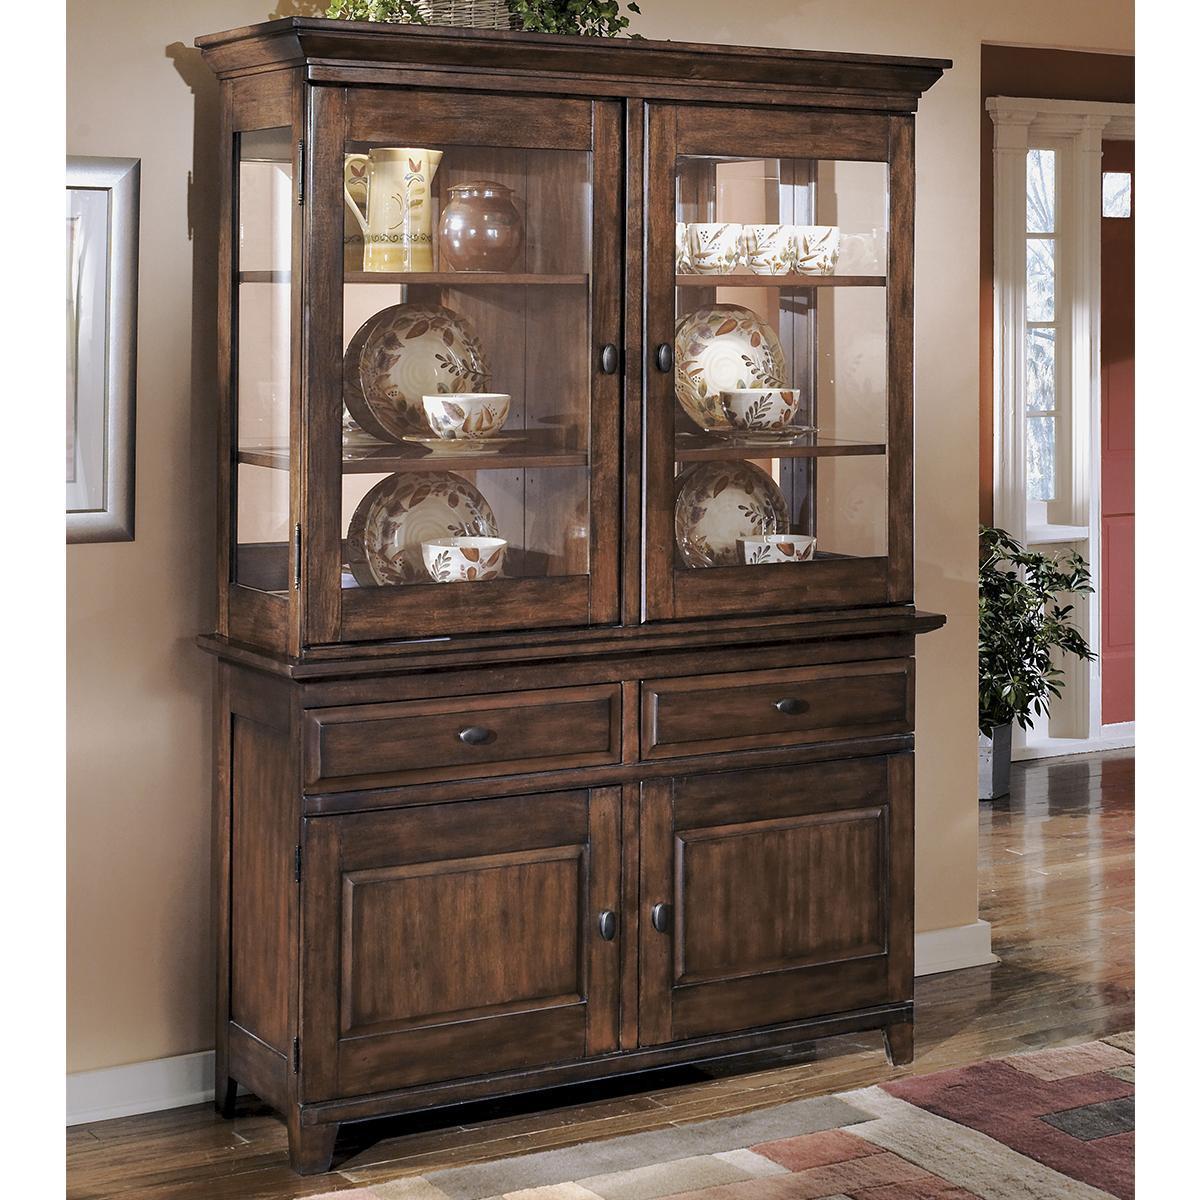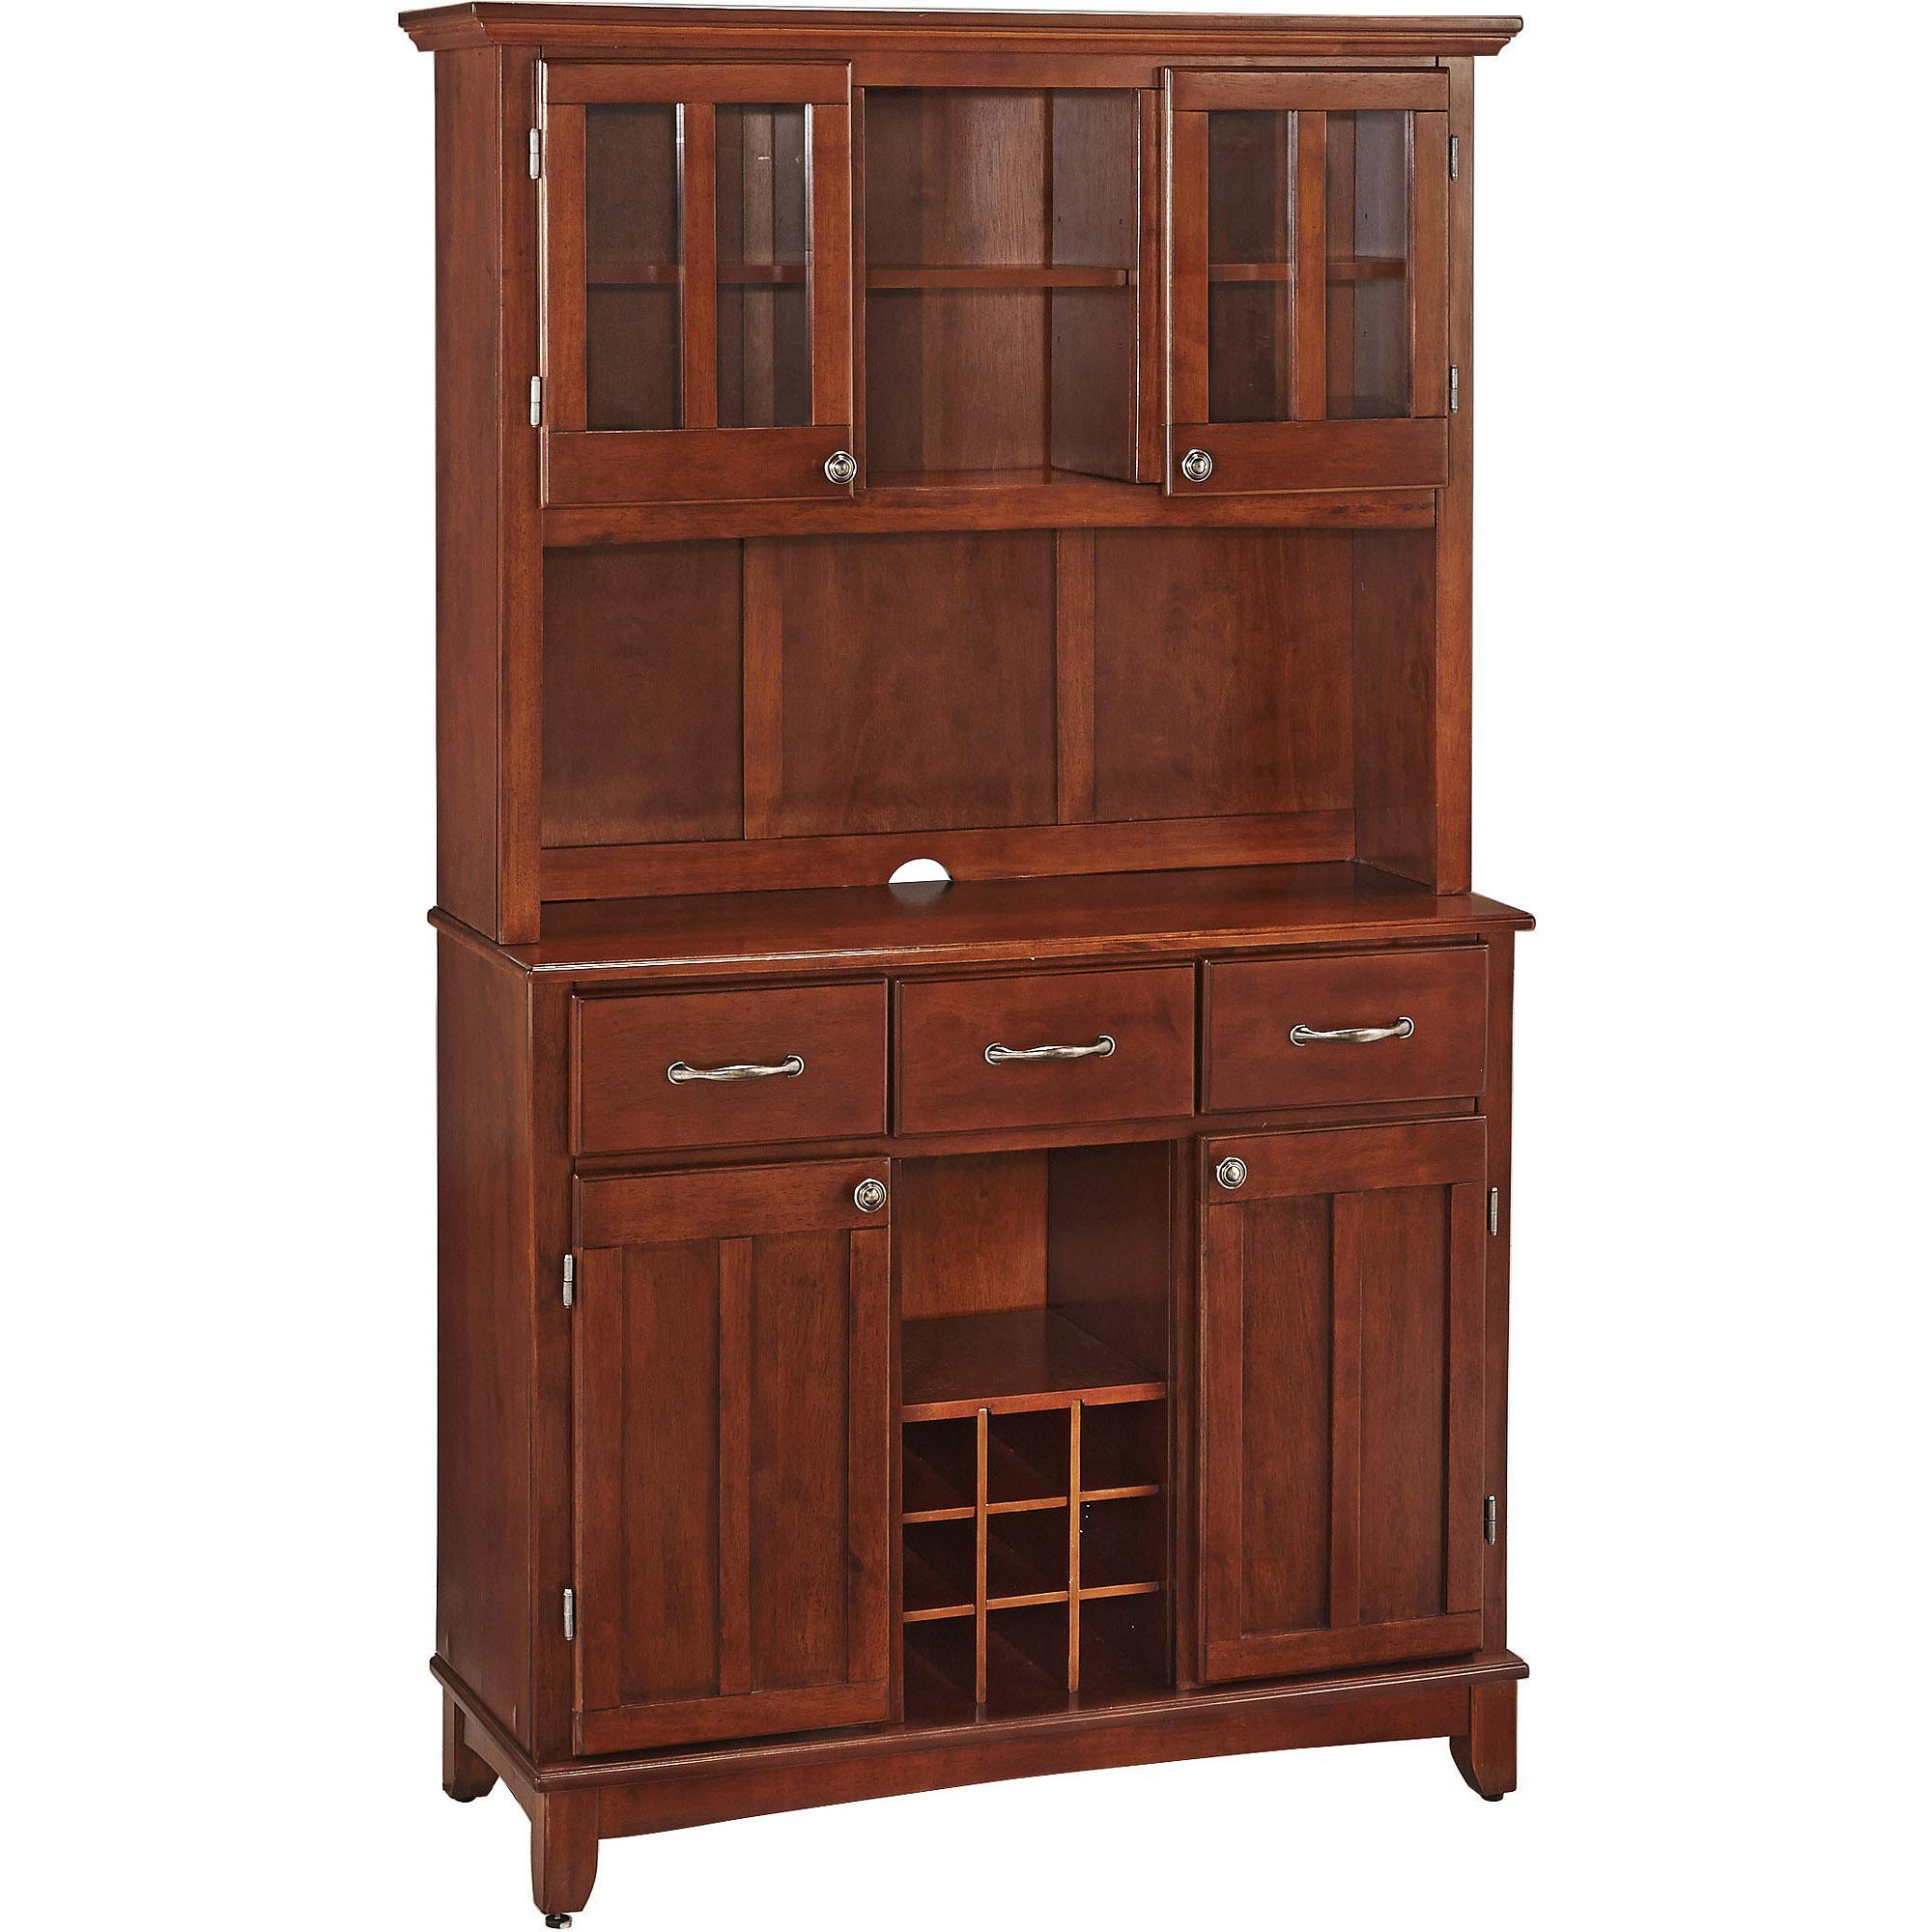The first image is the image on the left, the second image is the image on the right. For the images shown, is this caption "The left image features a lighter coloured cabinet with a middle column on its lower half." true? Answer yes or no. No. 